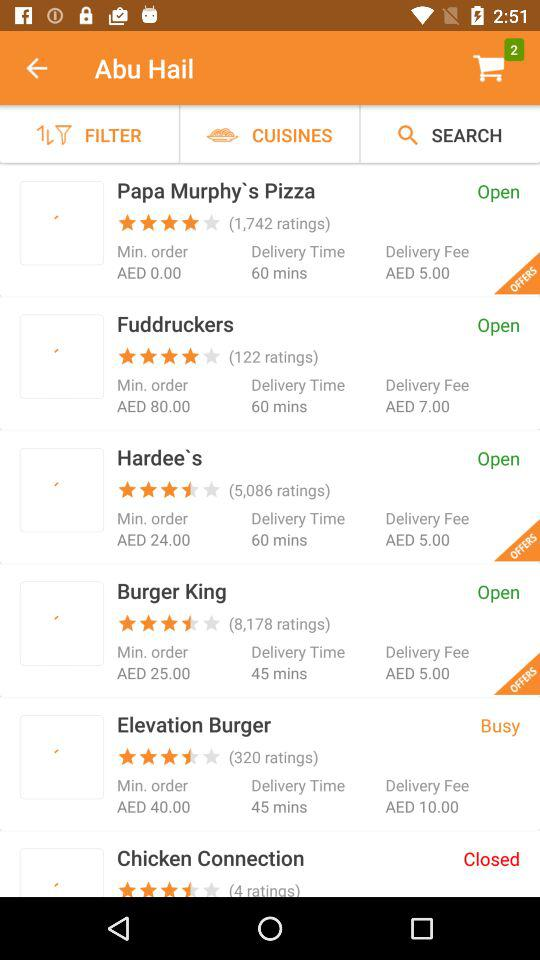What is the delivery time from Hardee's? The delivery time from Hardee's is 60 minutes. 